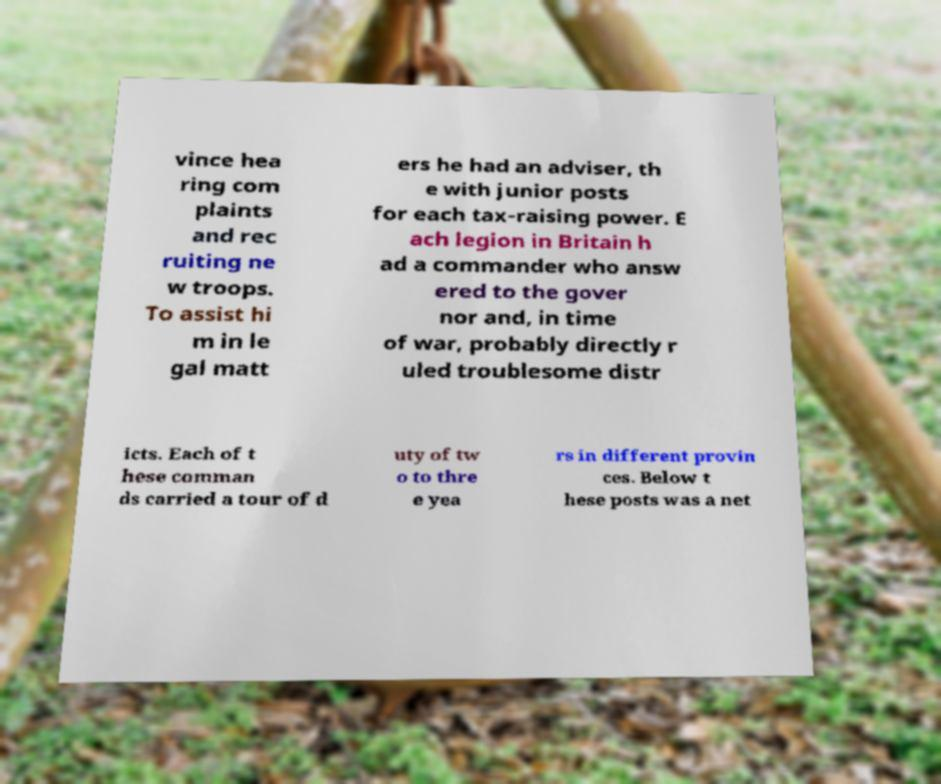Could you assist in decoding the text presented in this image and type it out clearly? vince hea ring com plaints and rec ruiting ne w troops. To assist hi m in le gal matt ers he had an adviser, th e with junior posts for each tax-raising power. E ach legion in Britain h ad a commander who answ ered to the gover nor and, in time of war, probably directly r uled troublesome distr icts. Each of t hese comman ds carried a tour of d uty of tw o to thre e yea rs in different provin ces. Below t hese posts was a net 